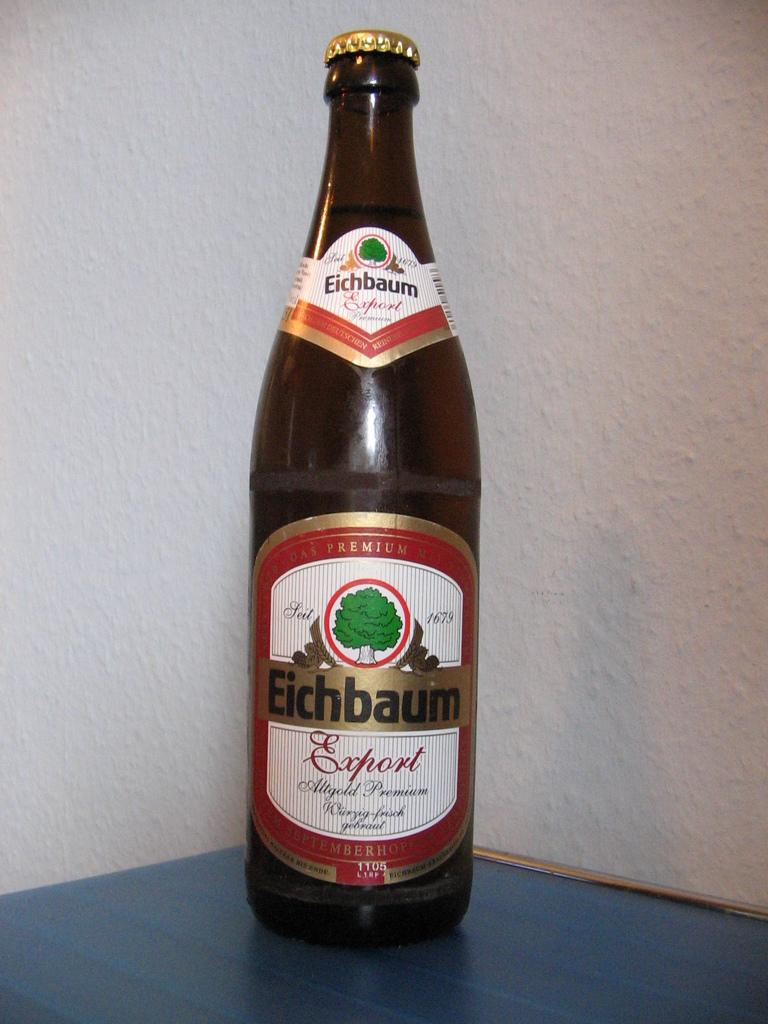<image>
Write a terse but informative summary of the picture. An unopened bottle of Eichbaum Export beer on a table. 